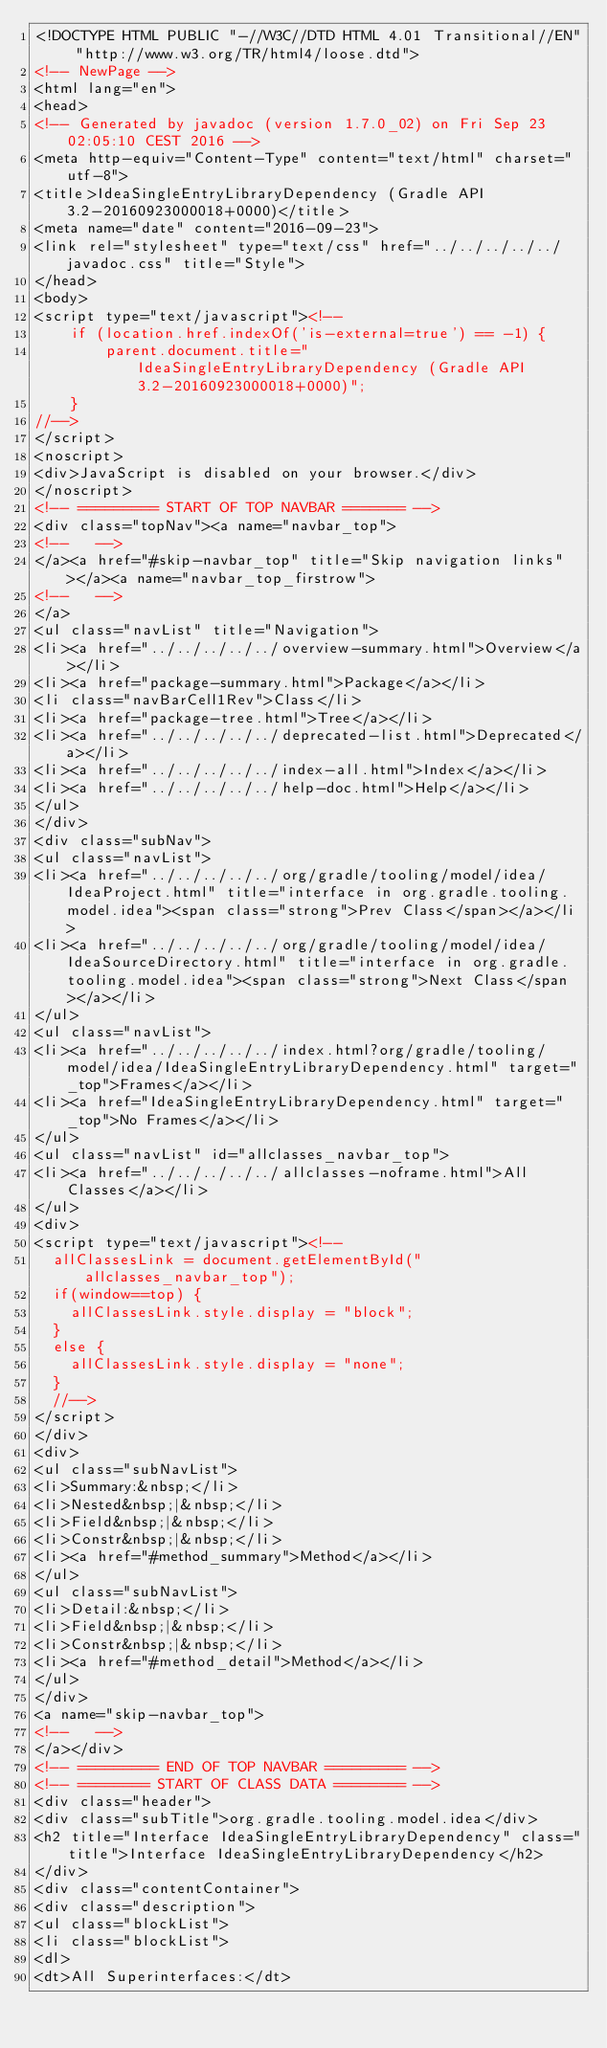<code> <loc_0><loc_0><loc_500><loc_500><_HTML_><!DOCTYPE HTML PUBLIC "-//W3C//DTD HTML 4.01 Transitional//EN" "http://www.w3.org/TR/html4/loose.dtd">
<!-- NewPage -->
<html lang="en">
<head>
<!-- Generated by javadoc (version 1.7.0_02) on Fri Sep 23 02:05:10 CEST 2016 -->
<meta http-equiv="Content-Type" content="text/html" charset="utf-8">
<title>IdeaSingleEntryLibraryDependency (Gradle API 3.2-20160923000018+0000)</title>
<meta name="date" content="2016-09-23">
<link rel="stylesheet" type="text/css" href="../../../../../javadoc.css" title="Style">
</head>
<body>
<script type="text/javascript"><!--
    if (location.href.indexOf('is-external=true') == -1) {
        parent.document.title="IdeaSingleEntryLibraryDependency (Gradle API 3.2-20160923000018+0000)";
    }
//-->
</script>
<noscript>
<div>JavaScript is disabled on your browser.</div>
</noscript>
<!-- ========= START OF TOP NAVBAR ======= -->
<div class="topNav"><a name="navbar_top">
<!--   -->
</a><a href="#skip-navbar_top" title="Skip navigation links"></a><a name="navbar_top_firstrow">
<!--   -->
</a>
<ul class="navList" title="Navigation">
<li><a href="../../../../../overview-summary.html">Overview</a></li>
<li><a href="package-summary.html">Package</a></li>
<li class="navBarCell1Rev">Class</li>
<li><a href="package-tree.html">Tree</a></li>
<li><a href="../../../../../deprecated-list.html">Deprecated</a></li>
<li><a href="../../../../../index-all.html">Index</a></li>
<li><a href="../../../../../help-doc.html">Help</a></li>
</ul>
</div>
<div class="subNav">
<ul class="navList">
<li><a href="../../../../../org/gradle/tooling/model/idea/IdeaProject.html" title="interface in org.gradle.tooling.model.idea"><span class="strong">Prev Class</span></a></li>
<li><a href="../../../../../org/gradle/tooling/model/idea/IdeaSourceDirectory.html" title="interface in org.gradle.tooling.model.idea"><span class="strong">Next Class</span></a></li>
</ul>
<ul class="navList">
<li><a href="../../../../../index.html?org/gradle/tooling/model/idea/IdeaSingleEntryLibraryDependency.html" target="_top">Frames</a></li>
<li><a href="IdeaSingleEntryLibraryDependency.html" target="_top">No Frames</a></li>
</ul>
<ul class="navList" id="allclasses_navbar_top">
<li><a href="../../../../../allclasses-noframe.html">All Classes</a></li>
</ul>
<div>
<script type="text/javascript"><!--
  allClassesLink = document.getElementById("allclasses_navbar_top");
  if(window==top) {
    allClassesLink.style.display = "block";
  }
  else {
    allClassesLink.style.display = "none";
  }
  //-->
</script>
</div>
<div>
<ul class="subNavList">
<li>Summary:&nbsp;</li>
<li>Nested&nbsp;|&nbsp;</li>
<li>Field&nbsp;|&nbsp;</li>
<li>Constr&nbsp;|&nbsp;</li>
<li><a href="#method_summary">Method</a></li>
</ul>
<ul class="subNavList">
<li>Detail:&nbsp;</li>
<li>Field&nbsp;|&nbsp;</li>
<li>Constr&nbsp;|&nbsp;</li>
<li><a href="#method_detail">Method</a></li>
</ul>
</div>
<a name="skip-navbar_top">
<!--   -->
</a></div>
<!-- ========= END OF TOP NAVBAR ========= -->
<!-- ======== START OF CLASS DATA ======== -->
<div class="header">
<div class="subTitle">org.gradle.tooling.model.idea</div>
<h2 title="Interface IdeaSingleEntryLibraryDependency" class="title">Interface IdeaSingleEntryLibraryDependency</h2>
</div>
<div class="contentContainer">
<div class="description">
<ul class="blockList">
<li class="blockList">
<dl>
<dt>All Superinterfaces:</dt></code> 